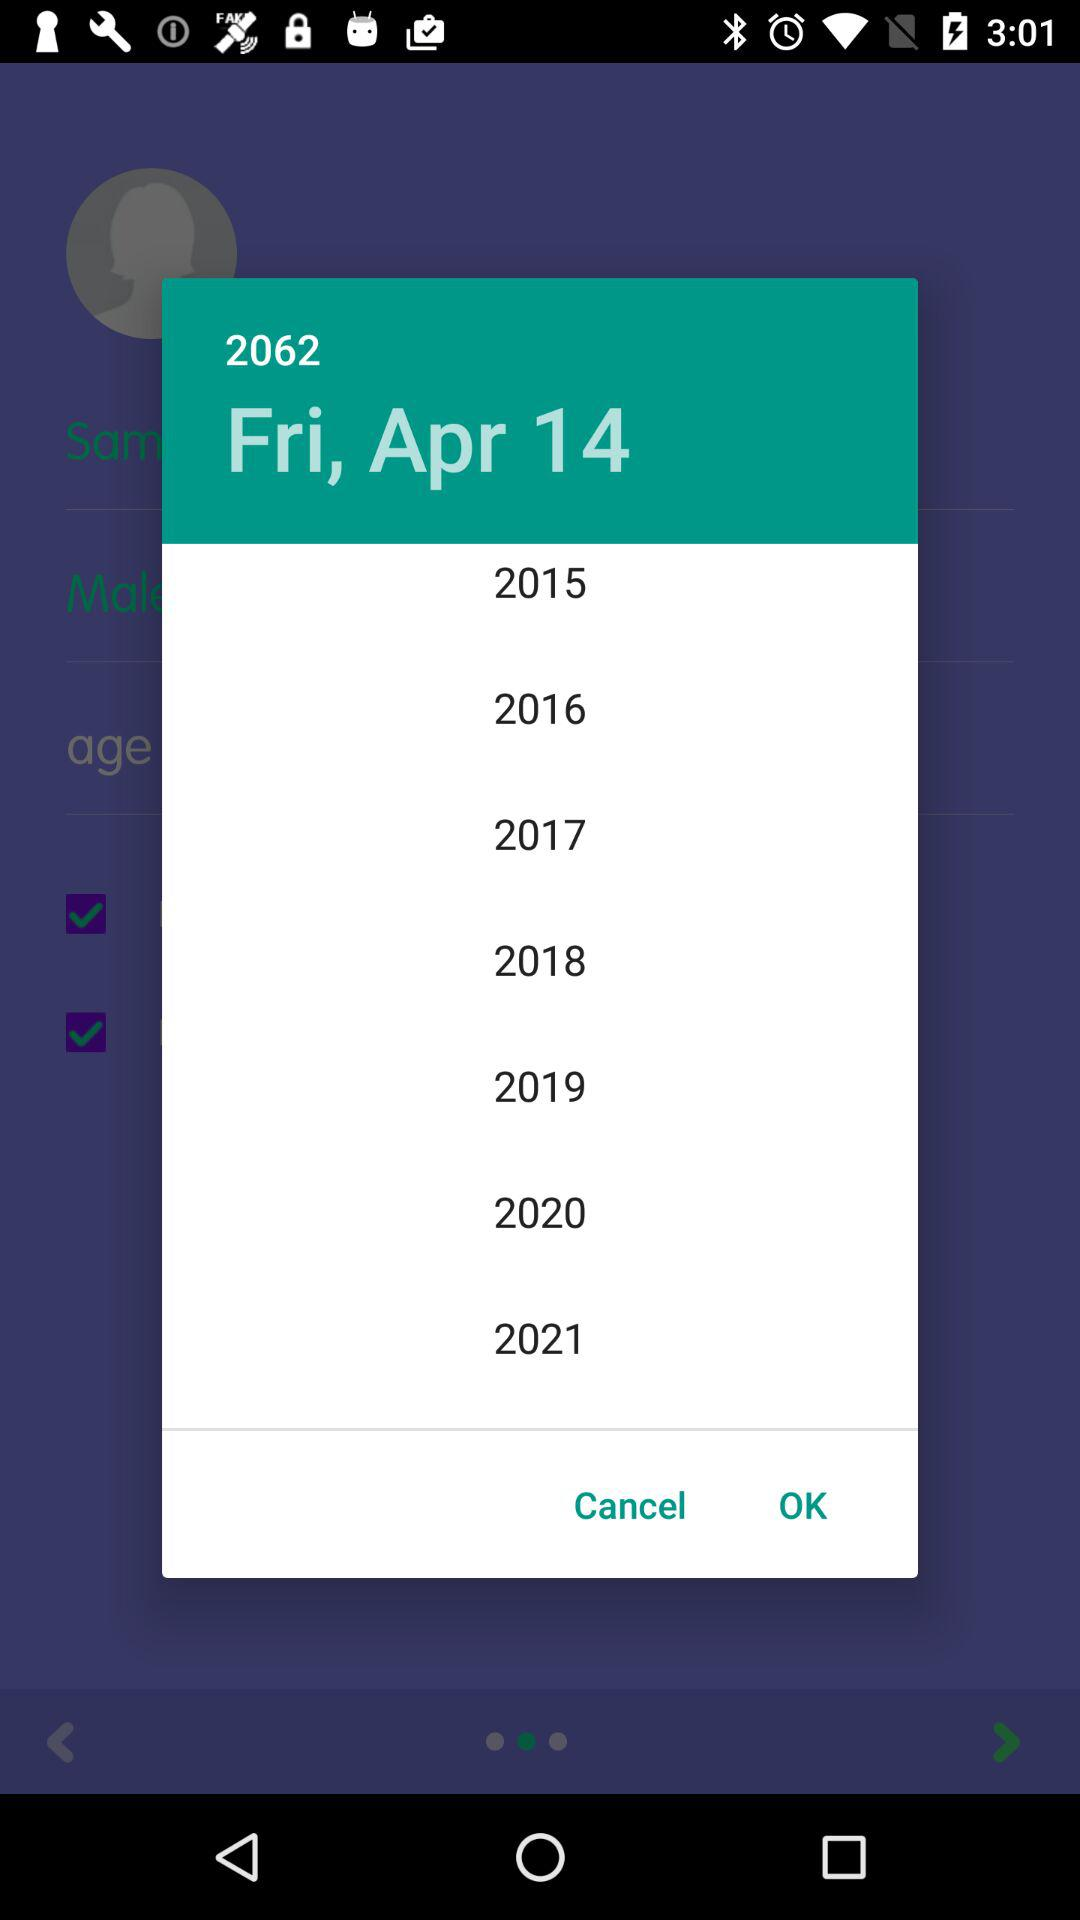Which date is selected? The selected date is Friday, April 14, 2062. 